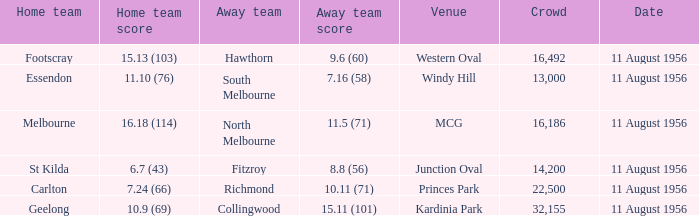What home team played at western oval? Footscray. 